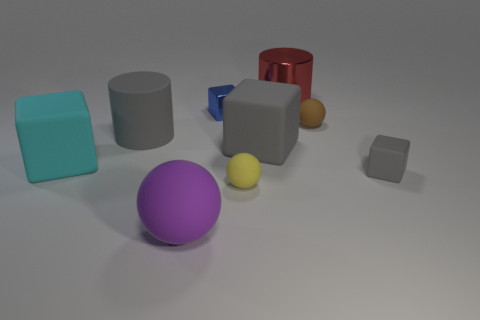Is there any other thing that has the same material as the blue block?
Provide a succinct answer. Yes. The brown sphere has what size?
Your answer should be very brief. Small. What is the color of the large rubber object that is on the right side of the large rubber cylinder and behind the small matte cube?
Offer a terse response. Gray. Are there more tiny gray metallic cylinders than cyan matte things?
Give a very brief answer. No. What number of things are either blue metal objects or tiny things in front of the large cyan matte object?
Provide a succinct answer. 3. Does the red cylinder have the same size as the yellow sphere?
Give a very brief answer. No. There is a small rubber cube; are there any big gray things in front of it?
Give a very brief answer. No. There is a block that is both in front of the tiny blue block and behind the big cyan matte thing; what size is it?
Keep it short and to the point. Large. How many objects are either big matte things or cyan cubes?
Make the answer very short. 4. There is a yellow ball; does it have the same size as the gray object that is to the left of the big matte ball?
Provide a succinct answer. No. 